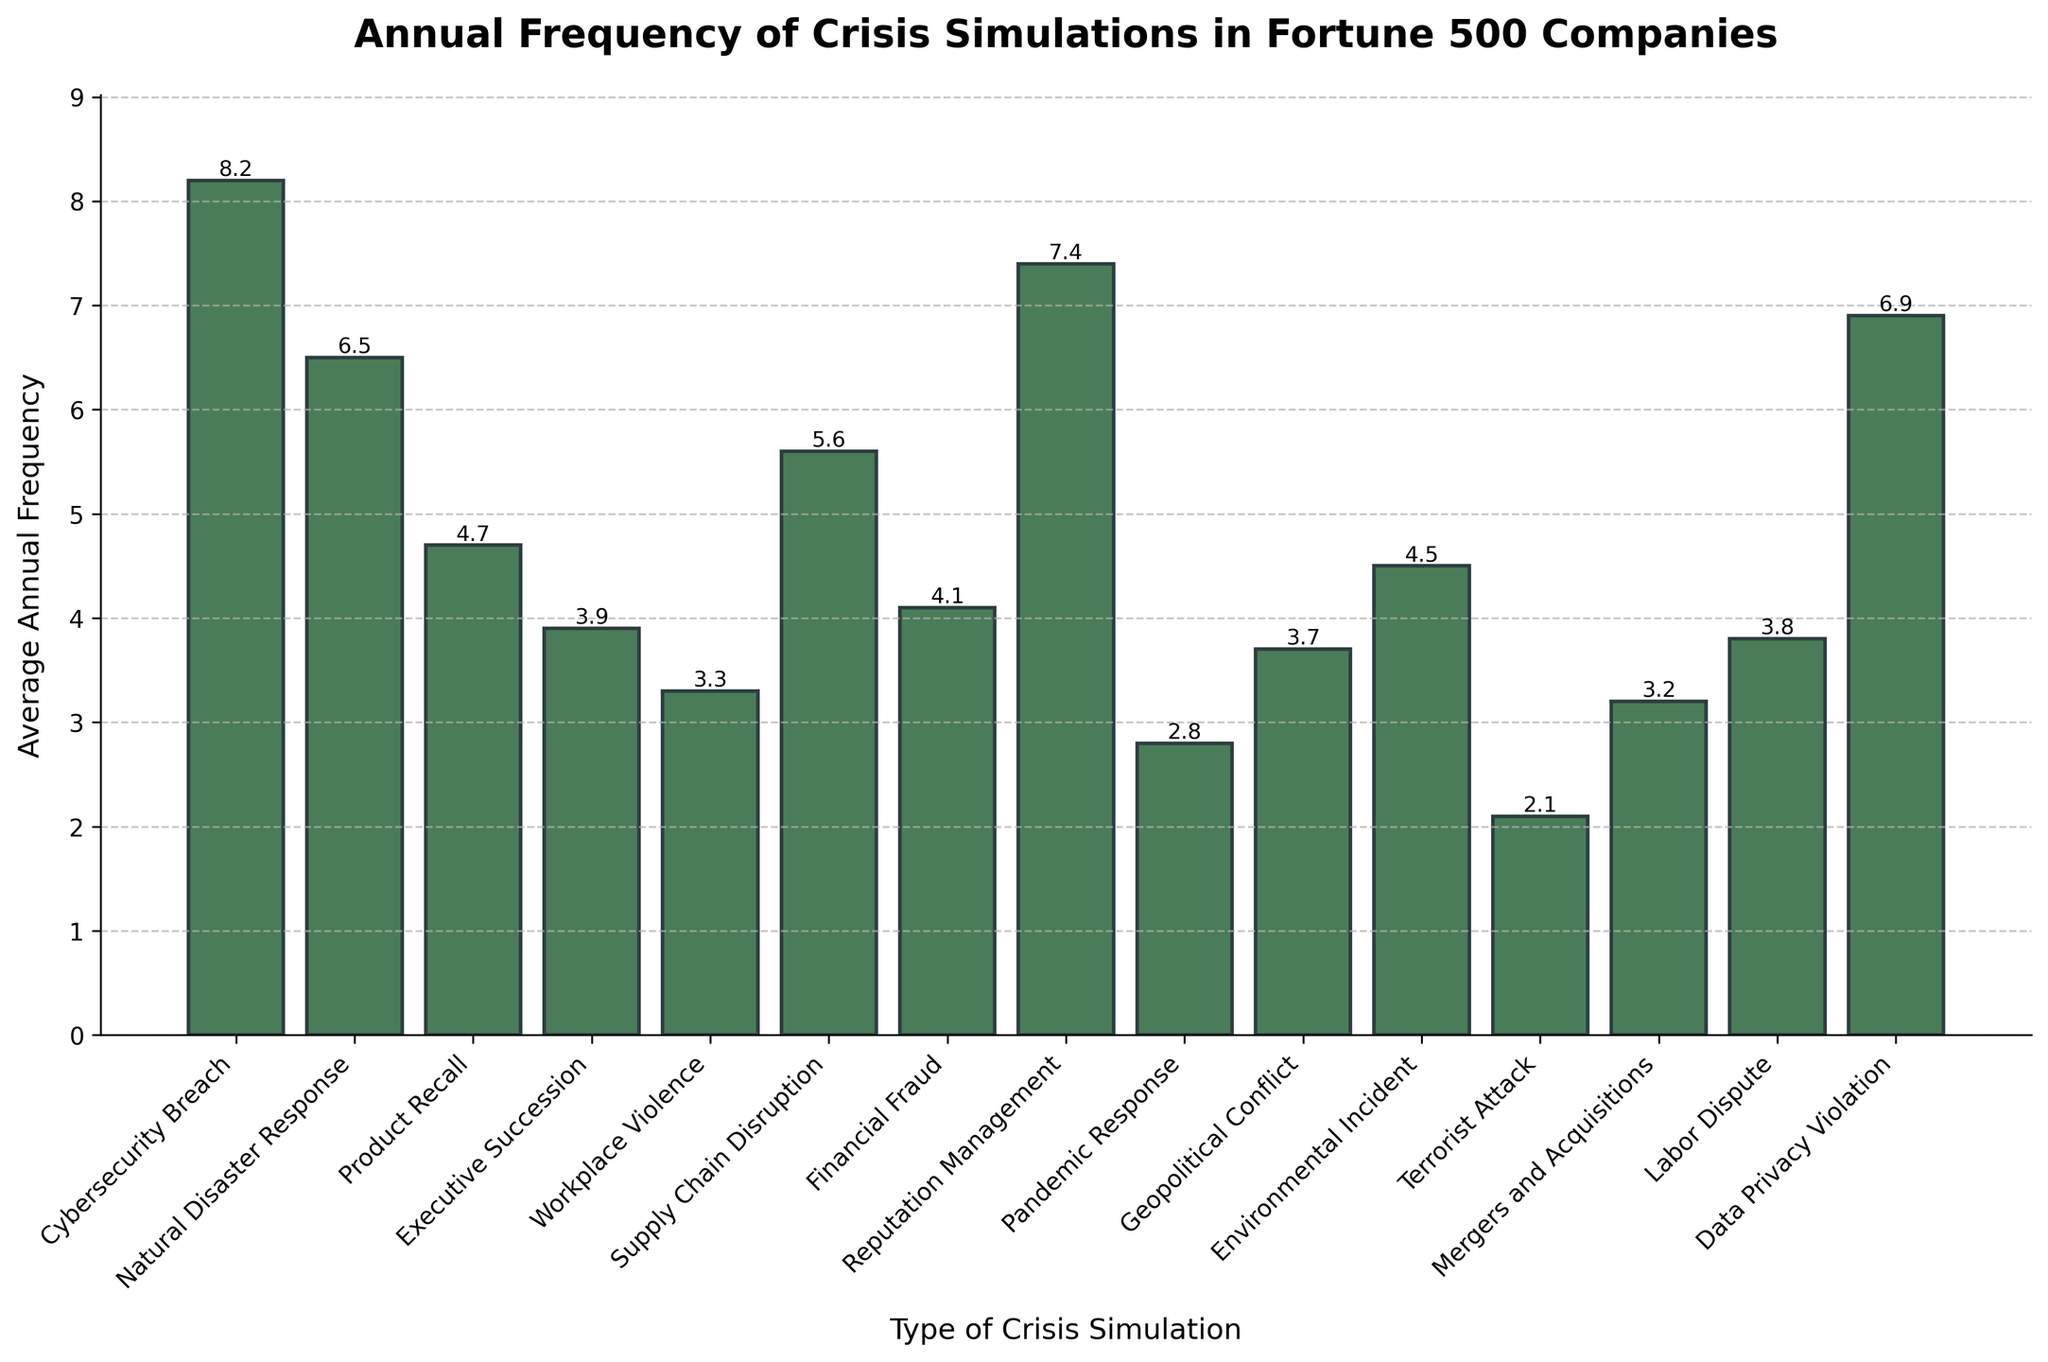What's the most frequently conducted crisis simulation? To determine the most frequently conducted crisis simulation, we need to identify the bar with the greatest height. The Cybersecurity Breach simulation has the highest average annual frequency at 8.2.
Answer: Cybersecurity Breach Which crisis simulation is conducted less frequently than Environmental Incident but more frequently than Executive Succession? First, locate the bars for Environmental Incident and Executive Succession. Environmental Incident has a frequency of 4.5 and Executive Succession has 3.9. The simulation in between is Financial Fraud with a frequency of 4.1.
Answer: Financial Fraud What is the combined average annual frequency of Natural Disaster Response and Reputation Management simulations? Add the frequencies of Natural Disaster Response (6.5) and Reputation Management (7.4). The sum is 6.5 + 7.4 = 13.9.
Answer: 13.9 Which two crisis simulations have the same frequency? Identify bars that are at the same height. The Geopolitical Conflict and Labor Dispute simulations both have a frequency of 3.8.
Answer: Geopolitical Conflict and Labor Dispute Is the average annual frequency of Data Privacy Violation simulations greater than that of Cybersecurity Breach simulations? Compare the heights of the two bars. Data Privacy Violation has a frequency of 6.9, which is less than Cybersecurity Breach's 8.2.
Answer: No What is the difference in average annual frequency between the most and least conducted simulations? Identify the highest and lowest frequencies: Cybersecurity Breach (8.2) and Terrorist Attack (2.1). Subtract the lowest from the highest, 8.2 - 2.1 = 6.1.
Answer: 6.1 Are there more simulations conducted on average annually for Workplace Violence or Mergers and Acquisitions? Compare the heights of the bars for Workplace Violence (3.3) and Mergers and Acquisitions (3.2). Workplace Violence has a slightly higher frequency.
Answer: Workplace Violence Which crisis simulation has an average annual frequency close to the median of all frequencies? Arrange the frequencies in ascending order and find the median: [2.1, 2.8, 3.2, 3.3, 3.7, 3.8, 3.9, 4.1, 4.5, 4.7, 5.6, 6.5, 6.9, 7.4, 8.2]. The median is 4.1, which corresponds to Financial Fraud.
Answer: Financial Fraud What is the total average annual frequency for all crisis simulations related to incidents or response? Sum frequencies of simulations containing "Incident" or "Response": Natural Disaster Response (6.5), Environmental Incident (4.5), and Pandemic Response (2.8). The total is 6.5 + 4.5 + 2.8 = 13.8.
Answer: 13.8 